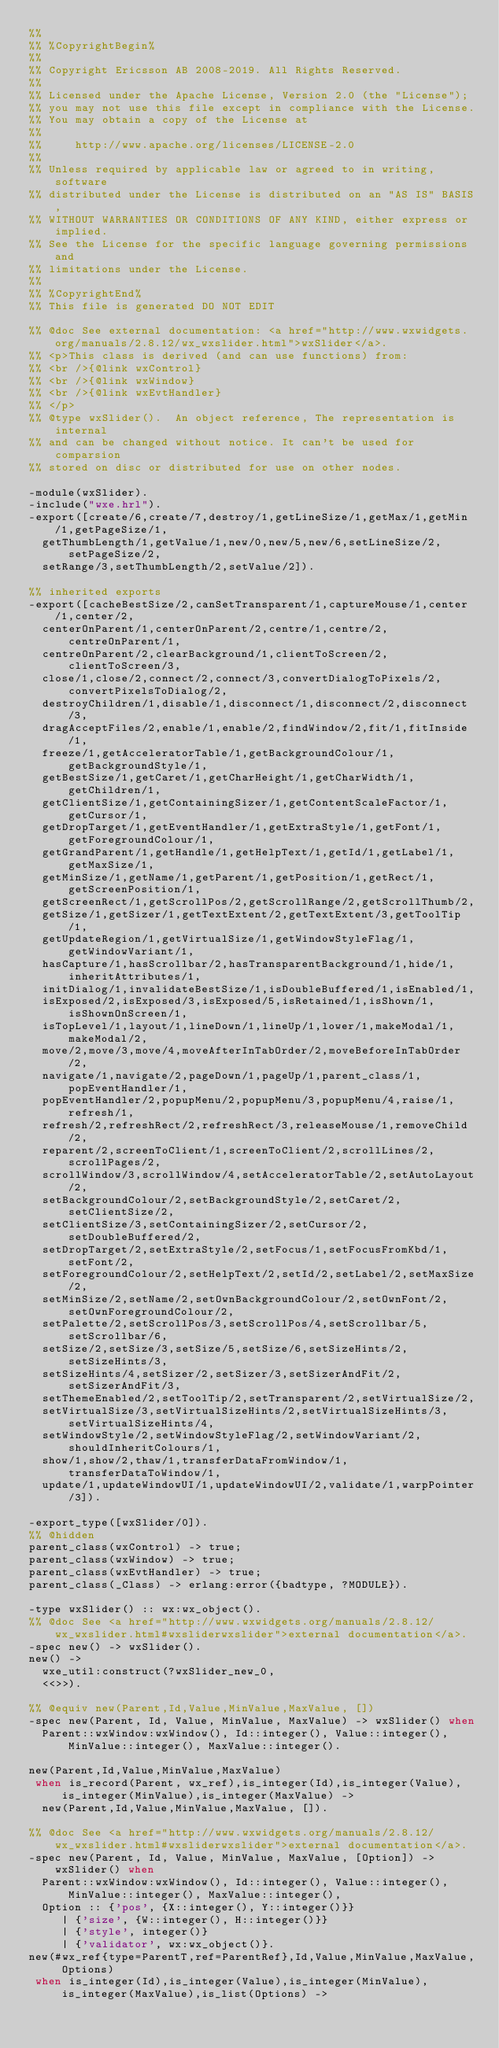<code> <loc_0><loc_0><loc_500><loc_500><_Erlang_>%%
%% %CopyrightBegin%
%%
%% Copyright Ericsson AB 2008-2019. All Rights Reserved.
%%
%% Licensed under the Apache License, Version 2.0 (the "License");
%% you may not use this file except in compliance with the License.
%% You may obtain a copy of the License at
%%
%%     http://www.apache.org/licenses/LICENSE-2.0
%%
%% Unless required by applicable law or agreed to in writing, software
%% distributed under the License is distributed on an "AS IS" BASIS,
%% WITHOUT WARRANTIES OR CONDITIONS OF ANY KIND, either express or implied.
%% See the License for the specific language governing permissions and
%% limitations under the License.
%%
%% %CopyrightEnd%
%% This file is generated DO NOT EDIT

%% @doc See external documentation: <a href="http://www.wxwidgets.org/manuals/2.8.12/wx_wxslider.html">wxSlider</a>.
%% <p>This class is derived (and can use functions) from:
%% <br />{@link wxControl}
%% <br />{@link wxWindow}
%% <br />{@link wxEvtHandler}
%% </p>
%% @type wxSlider().  An object reference, The representation is internal
%% and can be changed without notice. It can't be used for comparsion
%% stored on disc or distributed for use on other nodes.

-module(wxSlider).
-include("wxe.hrl").
-export([create/6,create/7,destroy/1,getLineSize/1,getMax/1,getMin/1,getPageSize/1,
  getThumbLength/1,getValue/1,new/0,new/5,new/6,setLineSize/2,setPageSize/2,
  setRange/3,setThumbLength/2,setValue/2]).

%% inherited exports
-export([cacheBestSize/2,canSetTransparent/1,captureMouse/1,center/1,center/2,
  centerOnParent/1,centerOnParent/2,centre/1,centre/2,centreOnParent/1,
  centreOnParent/2,clearBackground/1,clientToScreen/2,clientToScreen/3,
  close/1,close/2,connect/2,connect/3,convertDialogToPixels/2,convertPixelsToDialog/2,
  destroyChildren/1,disable/1,disconnect/1,disconnect/2,disconnect/3,
  dragAcceptFiles/2,enable/1,enable/2,findWindow/2,fit/1,fitInside/1,
  freeze/1,getAcceleratorTable/1,getBackgroundColour/1,getBackgroundStyle/1,
  getBestSize/1,getCaret/1,getCharHeight/1,getCharWidth/1,getChildren/1,
  getClientSize/1,getContainingSizer/1,getContentScaleFactor/1,getCursor/1,
  getDropTarget/1,getEventHandler/1,getExtraStyle/1,getFont/1,getForegroundColour/1,
  getGrandParent/1,getHandle/1,getHelpText/1,getId/1,getLabel/1,getMaxSize/1,
  getMinSize/1,getName/1,getParent/1,getPosition/1,getRect/1,getScreenPosition/1,
  getScreenRect/1,getScrollPos/2,getScrollRange/2,getScrollThumb/2,
  getSize/1,getSizer/1,getTextExtent/2,getTextExtent/3,getToolTip/1,
  getUpdateRegion/1,getVirtualSize/1,getWindowStyleFlag/1,getWindowVariant/1,
  hasCapture/1,hasScrollbar/2,hasTransparentBackground/1,hide/1,inheritAttributes/1,
  initDialog/1,invalidateBestSize/1,isDoubleBuffered/1,isEnabled/1,
  isExposed/2,isExposed/3,isExposed/5,isRetained/1,isShown/1,isShownOnScreen/1,
  isTopLevel/1,layout/1,lineDown/1,lineUp/1,lower/1,makeModal/1,makeModal/2,
  move/2,move/3,move/4,moveAfterInTabOrder/2,moveBeforeInTabOrder/2,
  navigate/1,navigate/2,pageDown/1,pageUp/1,parent_class/1,popEventHandler/1,
  popEventHandler/2,popupMenu/2,popupMenu/3,popupMenu/4,raise/1,refresh/1,
  refresh/2,refreshRect/2,refreshRect/3,releaseMouse/1,removeChild/2,
  reparent/2,screenToClient/1,screenToClient/2,scrollLines/2,scrollPages/2,
  scrollWindow/3,scrollWindow/4,setAcceleratorTable/2,setAutoLayout/2,
  setBackgroundColour/2,setBackgroundStyle/2,setCaret/2,setClientSize/2,
  setClientSize/3,setContainingSizer/2,setCursor/2,setDoubleBuffered/2,
  setDropTarget/2,setExtraStyle/2,setFocus/1,setFocusFromKbd/1,setFont/2,
  setForegroundColour/2,setHelpText/2,setId/2,setLabel/2,setMaxSize/2,
  setMinSize/2,setName/2,setOwnBackgroundColour/2,setOwnFont/2,setOwnForegroundColour/2,
  setPalette/2,setScrollPos/3,setScrollPos/4,setScrollbar/5,setScrollbar/6,
  setSize/2,setSize/3,setSize/5,setSize/6,setSizeHints/2,setSizeHints/3,
  setSizeHints/4,setSizer/2,setSizer/3,setSizerAndFit/2,setSizerAndFit/3,
  setThemeEnabled/2,setToolTip/2,setTransparent/2,setVirtualSize/2,
  setVirtualSize/3,setVirtualSizeHints/2,setVirtualSizeHints/3,setVirtualSizeHints/4,
  setWindowStyle/2,setWindowStyleFlag/2,setWindowVariant/2,shouldInheritColours/1,
  show/1,show/2,thaw/1,transferDataFromWindow/1,transferDataToWindow/1,
  update/1,updateWindowUI/1,updateWindowUI/2,validate/1,warpPointer/3]).

-export_type([wxSlider/0]).
%% @hidden
parent_class(wxControl) -> true;
parent_class(wxWindow) -> true;
parent_class(wxEvtHandler) -> true;
parent_class(_Class) -> erlang:error({badtype, ?MODULE}).

-type wxSlider() :: wx:wx_object().
%% @doc See <a href="http://www.wxwidgets.org/manuals/2.8.12/wx_wxslider.html#wxsliderwxslider">external documentation</a>.
-spec new() -> wxSlider().
new() ->
  wxe_util:construct(?wxSlider_new_0,
  <<>>).

%% @equiv new(Parent,Id,Value,MinValue,MaxValue, [])
-spec new(Parent, Id, Value, MinValue, MaxValue) -> wxSlider() when
	Parent::wxWindow:wxWindow(), Id::integer(), Value::integer(), MinValue::integer(), MaxValue::integer().

new(Parent,Id,Value,MinValue,MaxValue)
 when is_record(Parent, wx_ref),is_integer(Id),is_integer(Value),is_integer(MinValue),is_integer(MaxValue) ->
  new(Parent,Id,Value,MinValue,MaxValue, []).

%% @doc See <a href="http://www.wxwidgets.org/manuals/2.8.12/wx_wxslider.html#wxsliderwxslider">external documentation</a>.
-spec new(Parent, Id, Value, MinValue, MaxValue, [Option]) -> wxSlider() when
	Parent::wxWindow:wxWindow(), Id::integer(), Value::integer(), MinValue::integer(), MaxValue::integer(),
	Option :: {'pos', {X::integer(), Y::integer()}}
		 | {'size', {W::integer(), H::integer()}}
		 | {'style', integer()}
		 | {'validator', wx:wx_object()}.
new(#wx_ref{type=ParentT,ref=ParentRef},Id,Value,MinValue,MaxValue, Options)
 when is_integer(Id),is_integer(Value),is_integer(MinValue),is_integer(MaxValue),is_list(Options) -></code> 